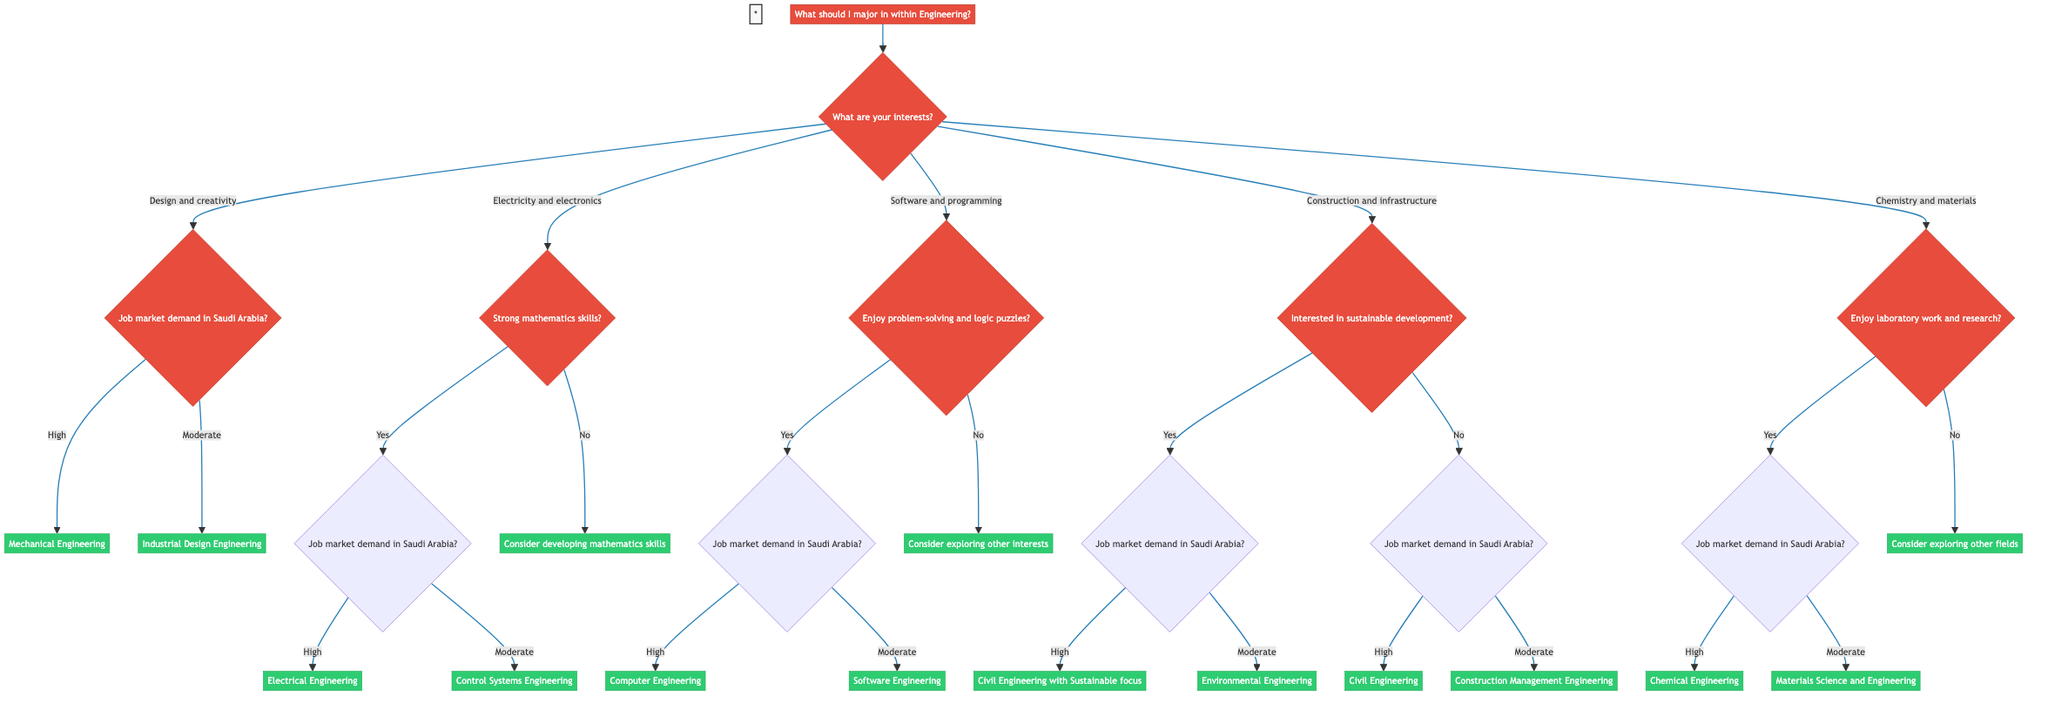What are the options under "Design and creativity"? The options following the "Design and creativity" interest node are determined by the job market demand in Saudi Arabia, which leads to either "Mechanical Engineering" for high demand or "Industrial Design Engineering" for moderate demand.
Answer: Mechanical Engineering, Industrial Design Engineering What should someone consider if they lack strong mathematics skills? If someone does not have strong mathematics skills in relation to the "Electricity and electronics" interest, the result advises them to "Consider further developing mathematics skills before deciding."
Answer: Consider developing mathematics skills How many main interest categories are listed in the decision tree? The main interests presented in the decision tree under the first question include five categories: Design and creativity, Electricity and electronics, Software and programming, Construction and infrastructure, and Chemistry and materials. Thus, there are five distinct interests.
Answer: Five Which major is suggested if the job market demand is high under "Electricity and electronics"? If the job market demand is high under the "Electricity and electronics" option and the individual has strong mathematics skills, the result would be "Electrical Engineering" based on the pathway through the decision tree.
Answer: Electrical Engineering What is the outcome for someone who enjoys laboratory work under "Chemistry and materials"? If a person enjoys laboratory work and research in the "Chemistry and materials" category, they will move to the next question regarding job market demand. If the demand is high, the outcome will be "Chemical Engineering," otherwise it will be "Materials Science and Engineering."
Answer: Chemical Engineering, Materials Science and Engineering What major falls under the "Software and programming" interest if someone enjoys problem-solving? If someone expresses enjoyment for problem-solving and logic puzzles under "Software and programming," they will proceed to the job market demand question, which could suggest either "Computer Engineering" for high demand or "Software Engineering" for moderate demand.
Answer: Computer Engineering, Software Engineering What is the result for someone interested in sustainable development in the field of construction? For individuals interested in sustainable development within "Construction and infrastructure," if the job market demand is high, the suggested outcome will be "Civil Engineering with a focus on Sustainable Engineering."
Answer: Civil Engineering with Sustainable focus If someone does not enjoy problem-solving, what should they do under "Software and programming"? If an individual does not enjoy problem-solving and logic puzzles under "Software and programming," the result indicates that they should "Consider exploring other areas of interest."
Answer: Consider exploring other areas of interest 